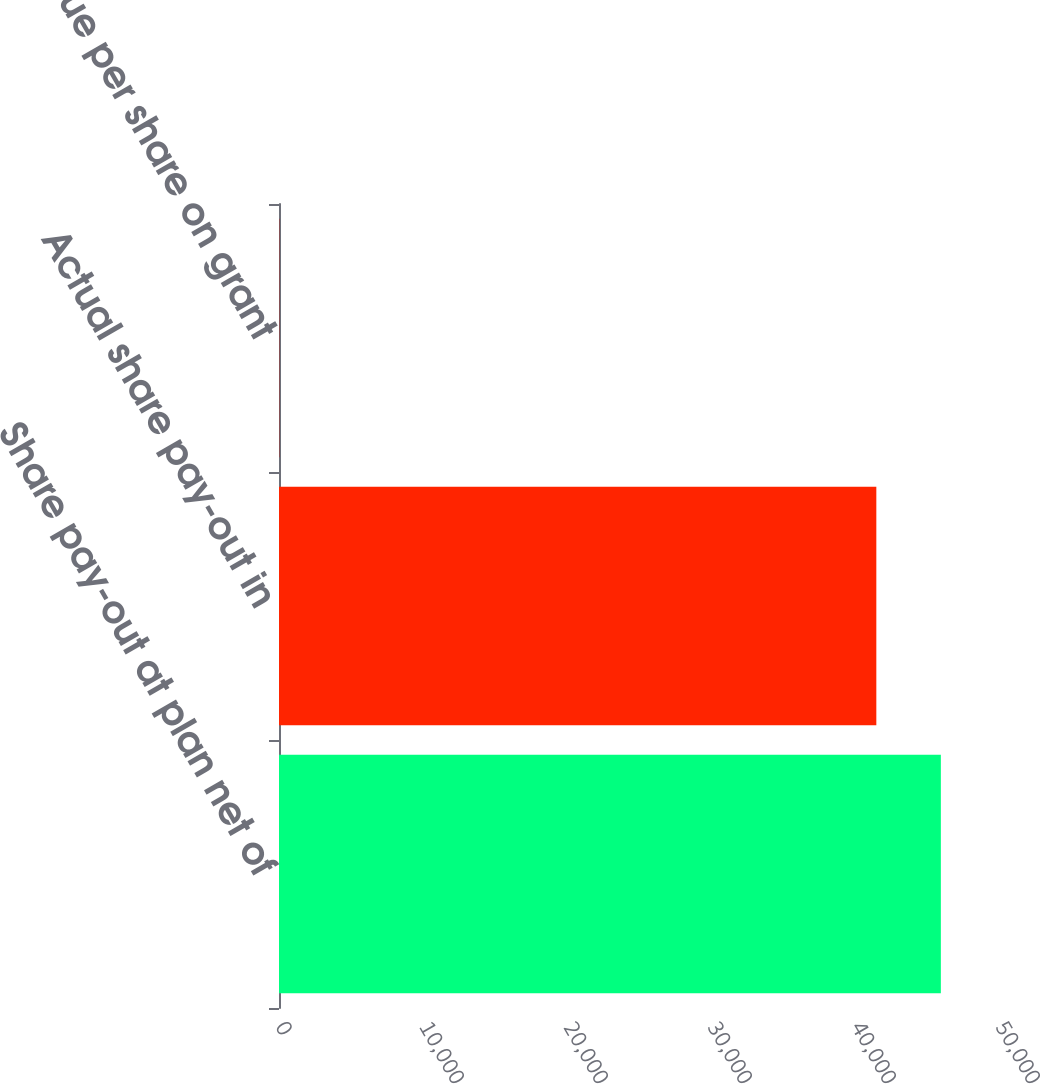Convert chart to OTSL. <chart><loc_0><loc_0><loc_500><loc_500><bar_chart><fcel>Share pay-out at plan net of<fcel>Actual share pay-out in<fcel>Fair value per share on grant<nl><fcel>45962.2<fcel>41481<fcel>30.64<nl></chart> 